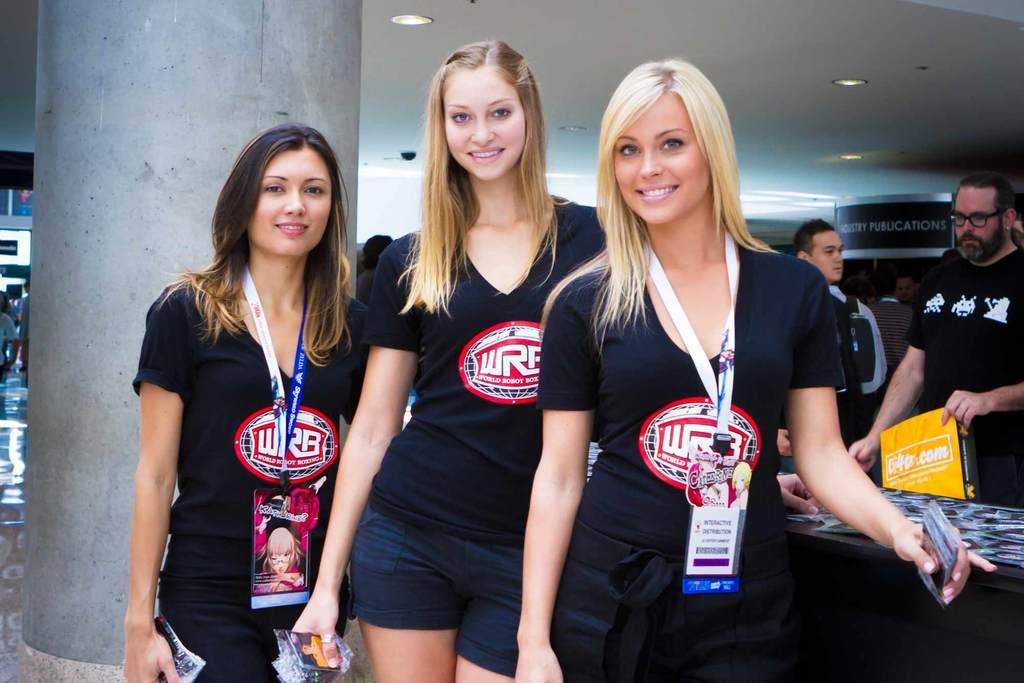<image>
Describe the image concisely. Three women in black WRB t-shirts are together at an event. 